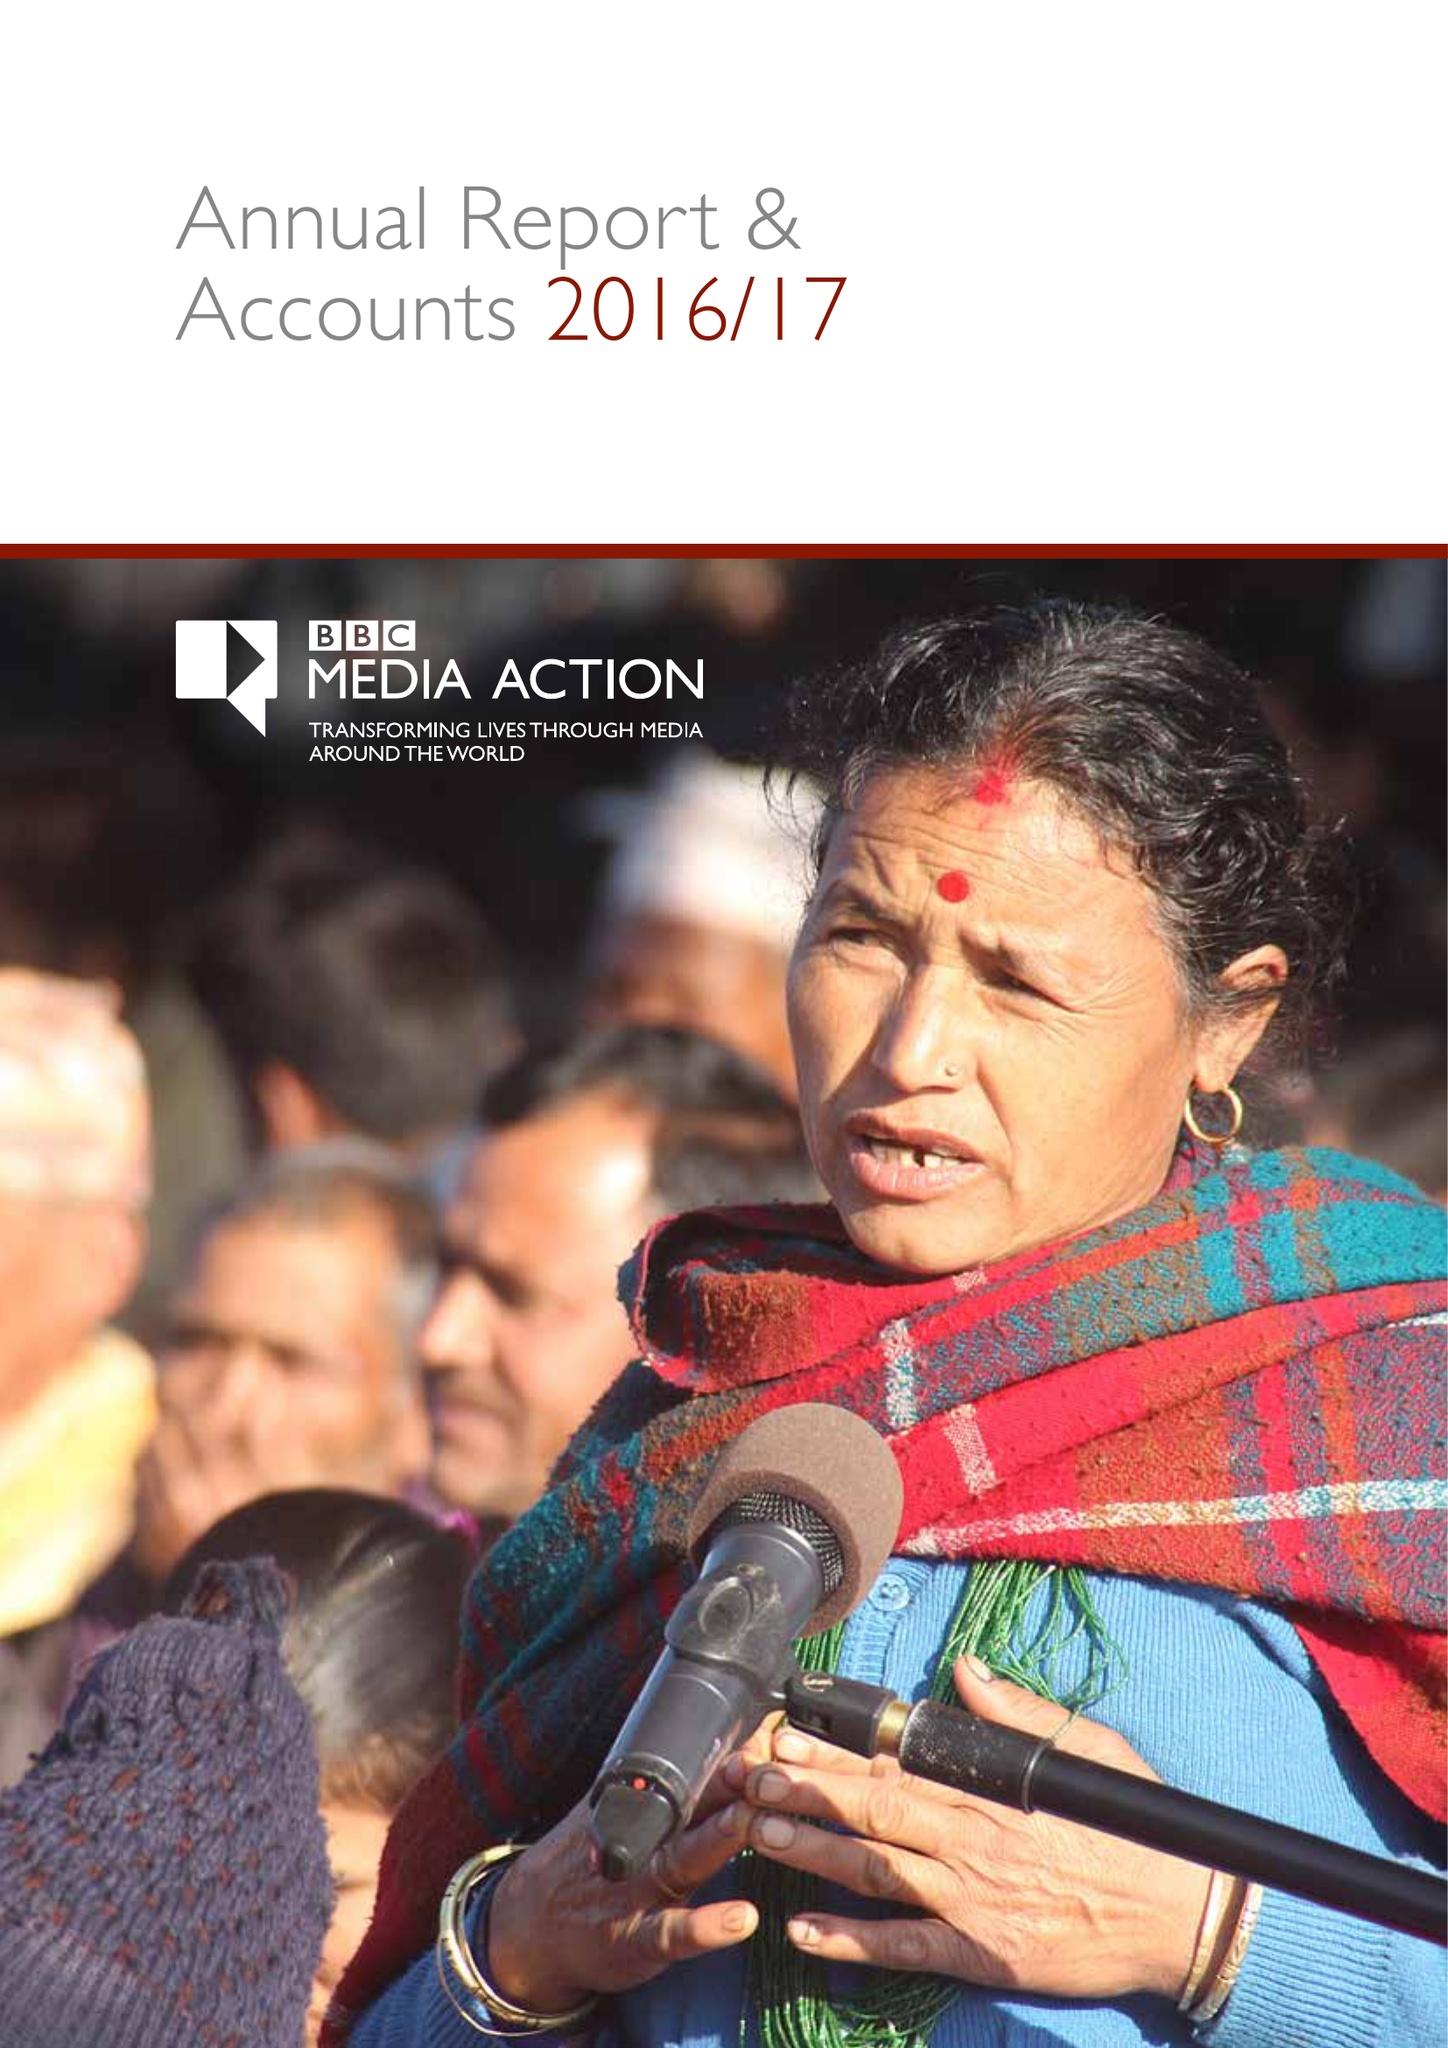What is the value for the charity_number?
Answer the question using a single word or phrase. 1076235 